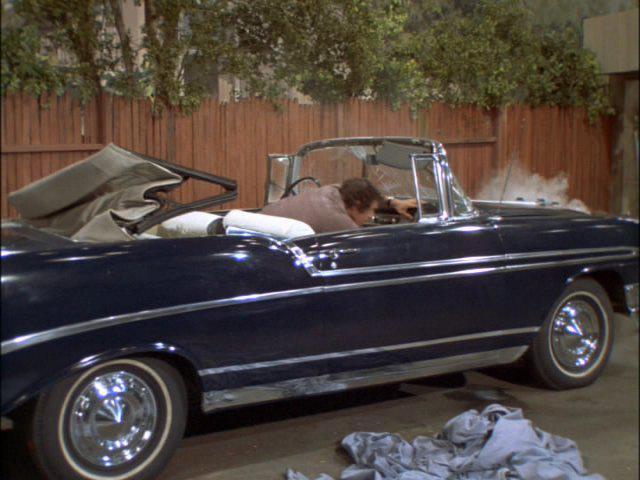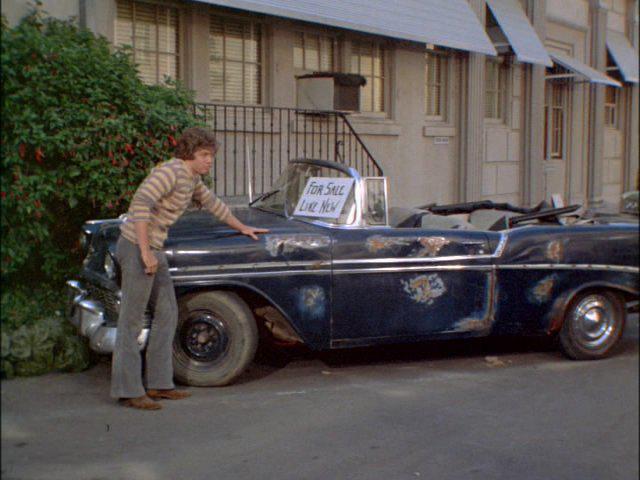The first image is the image on the left, the second image is the image on the right. Assess this claim about the two images: "A young fellow bends and touches the front of a beat-up looking dark blue convertiblee.". Correct or not? Answer yes or no. Yes. The first image is the image on the left, the second image is the image on the right. For the images shown, is this caption "There is exactly one car in the right image that is parked beside a wooden fence." true? Answer yes or no. No. 